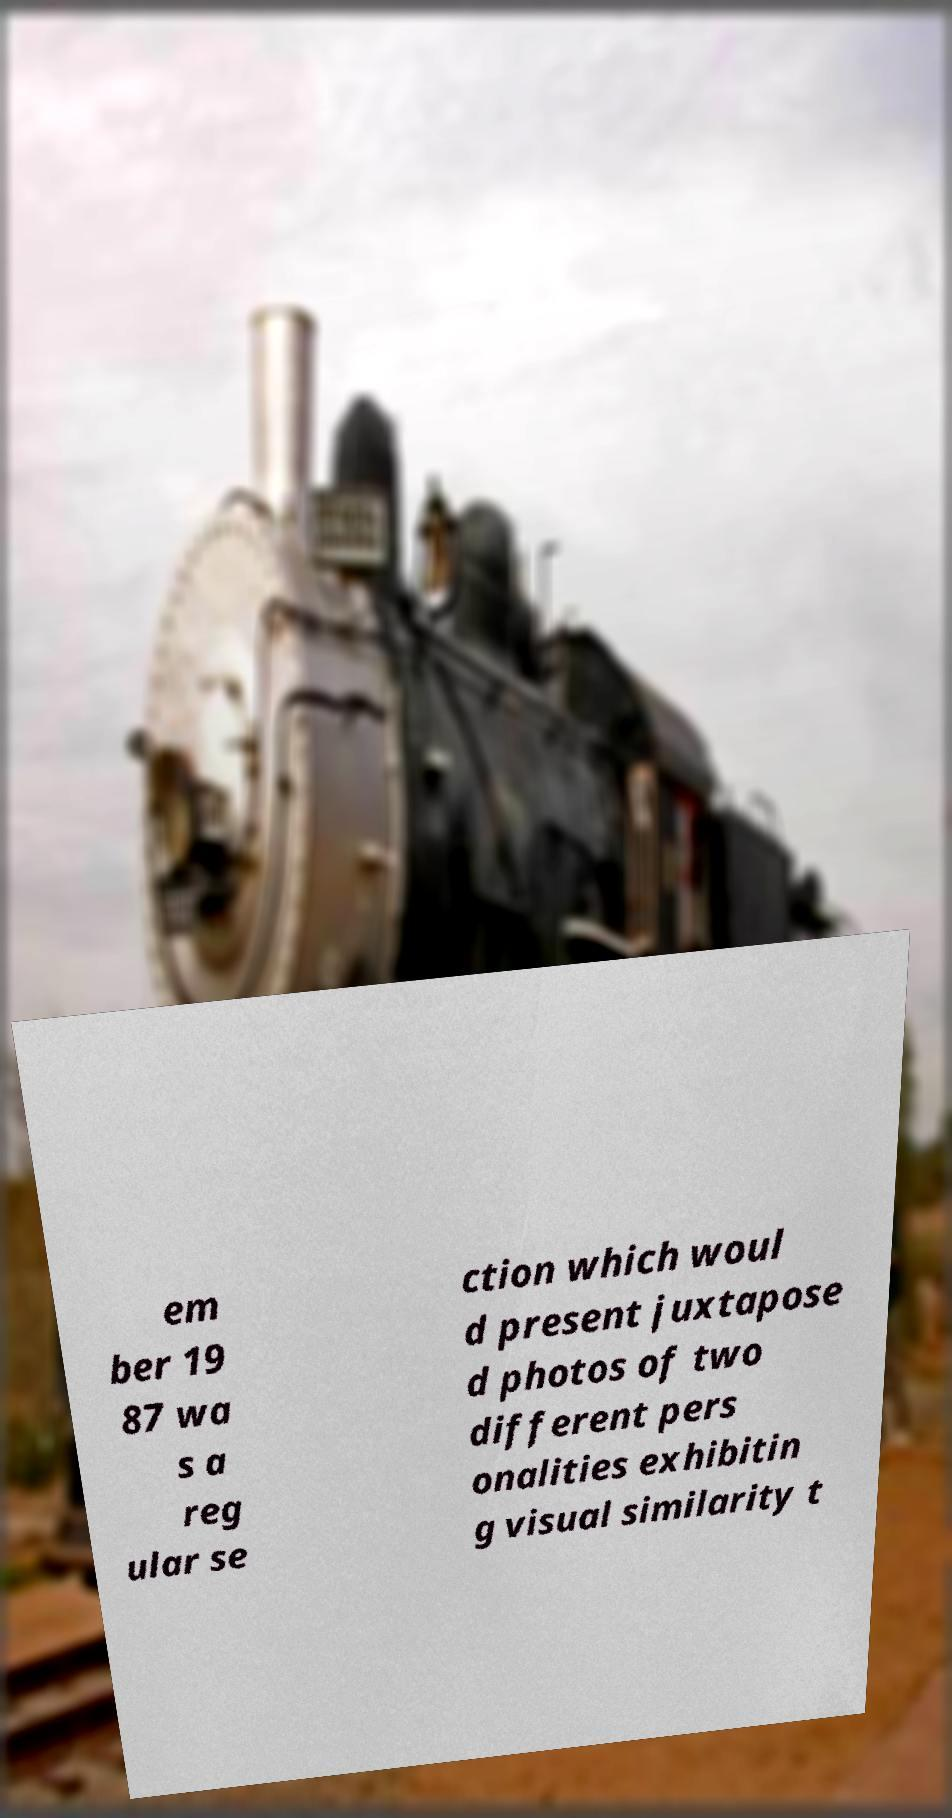Please identify and transcribe the text found in this image. em ber 19 87 wa s a reg ular se ction which woul d present juxtapose d photos of two different pers onalities exhibitin g visual similarity t 